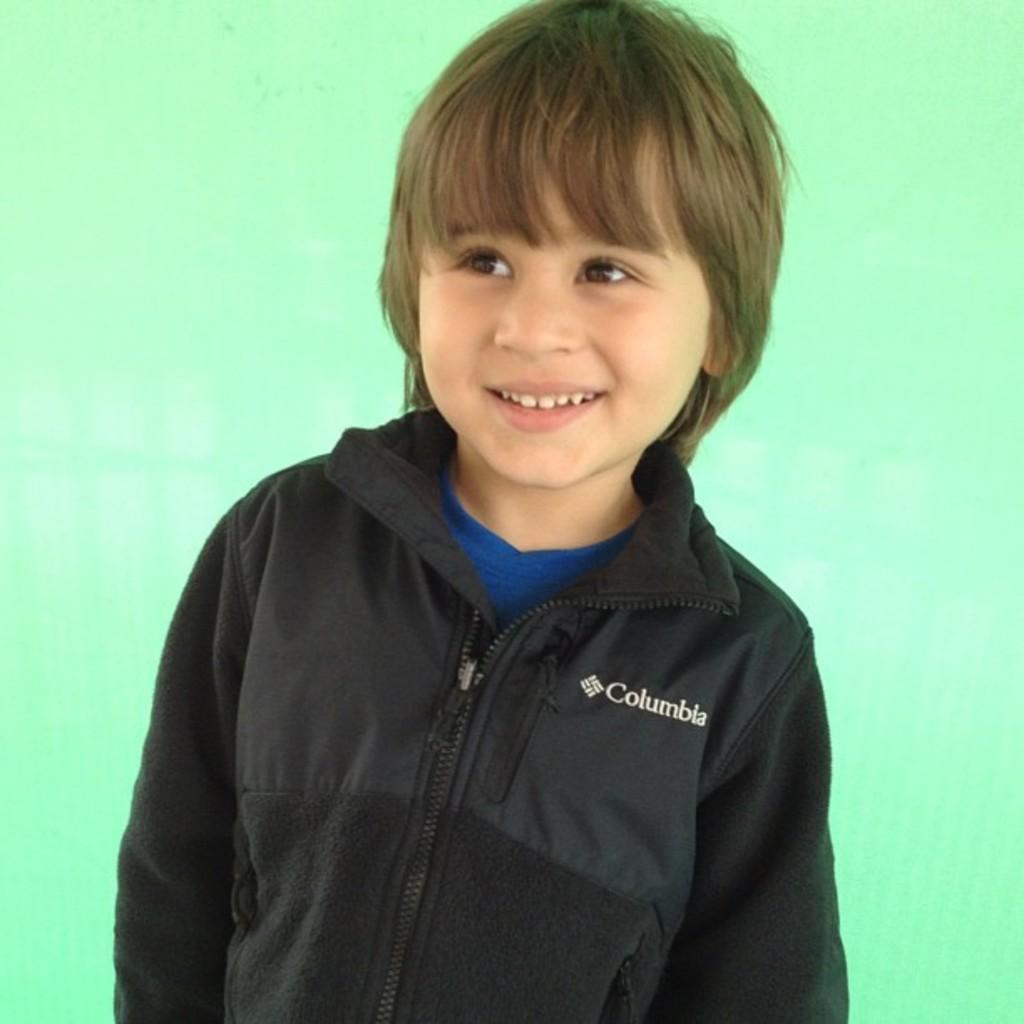In one or two sentences, can you explain what this image depicts? In this image we can see a boy and he is smiling. There is a green color background. 